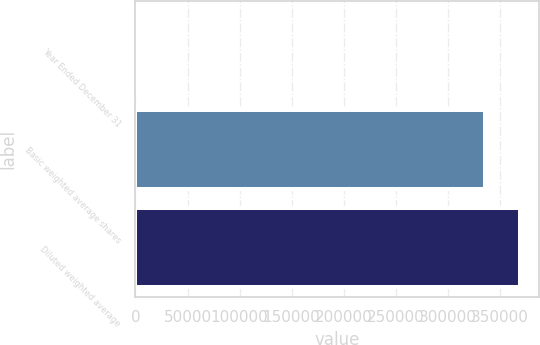Convert chart to OTSL. <chart><loc_0><loc_0><loc_500><loc_500><bar_chart><fcel>Year Ended December 31<fcel>Basic weighted average shares<fcel>Diluted weighted average<nl><fcel>2014<fcel>335192<fcel>369124<nl></chart> 